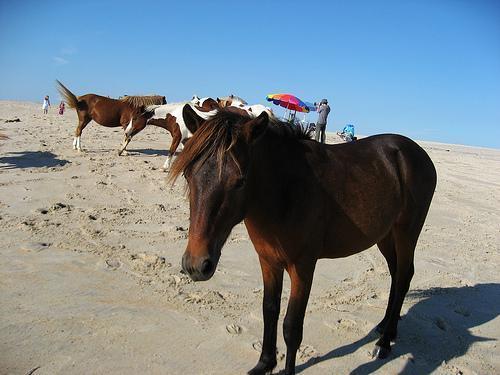How many horses in the picture?
Give a very brief answer. 5. How many legs does a horse have?
Give a very brief answer. 4. 